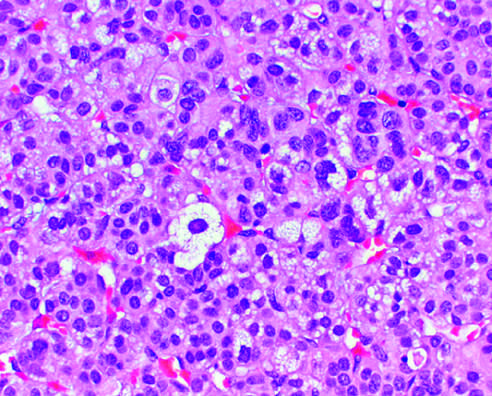what are the neoplastic cells vacuolated because of?
Answer the question using a single word or phrase. The presence of intracytoplasmic lipid 